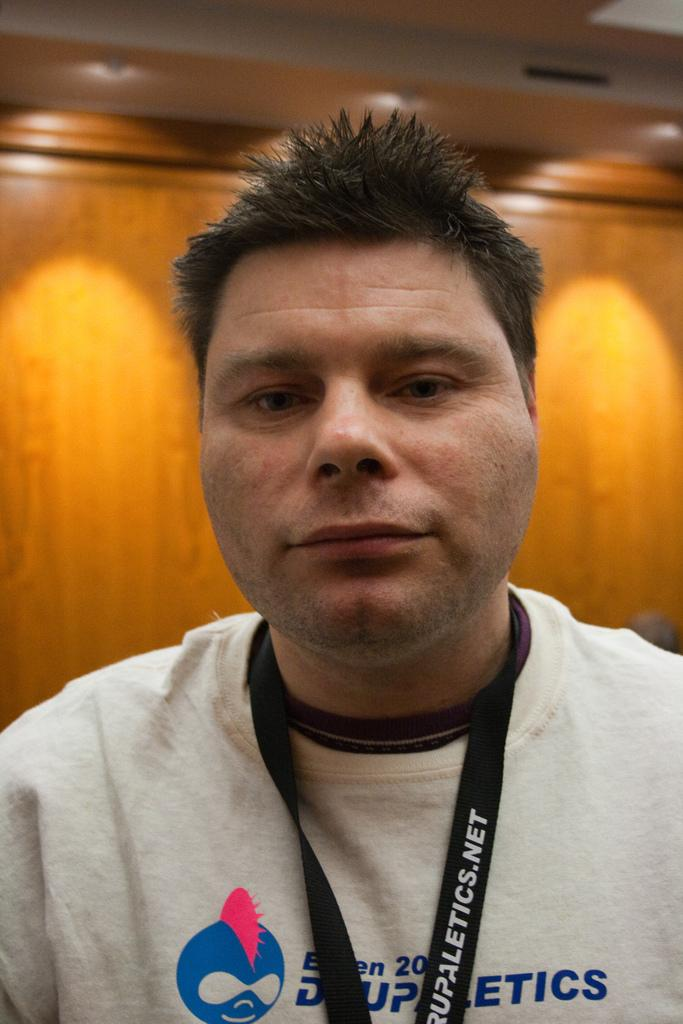Provide a one-sentence caption for the provided image. A man poses with a lanyard from drupaletics.net. 